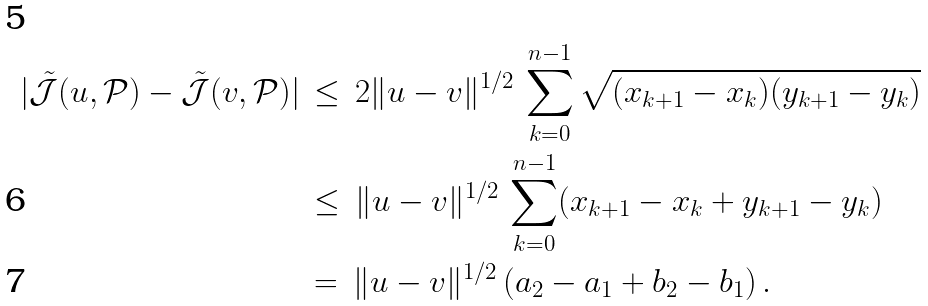<formula> <loc_0><loc_0><loc_500><loc_500>| \tilde { \mathcal { J } } ( u , \mathcal { P } ) - \tilde { \mathcal { J } } ( v , \mathcal { P } ) | \, & \leq \, 2 \| u - v \| ^ { 1 / 2 } \, \sum _ { k = 0 } ^ { n - 1 } \sqrt { ( x _ { k + 1 } - x _ { k } ) ( y _ { k + 1 } - y _ { k } ) } \\ & \leq \, \| u - v \| ^ { 1 / 2 } \, \sum _ { k = 0 } ^ { n - 1 } ( x _ { k + 1 } - x _ { k } + y _ { k + 1 } - y _ { k } ) \\ & = \, \| u - v \| ^ { 1 / 2 } \, ( a _ { 2 } - a _ { 1 } + b _ { 2 } - b _ { 1 } ) \, .</formula> 